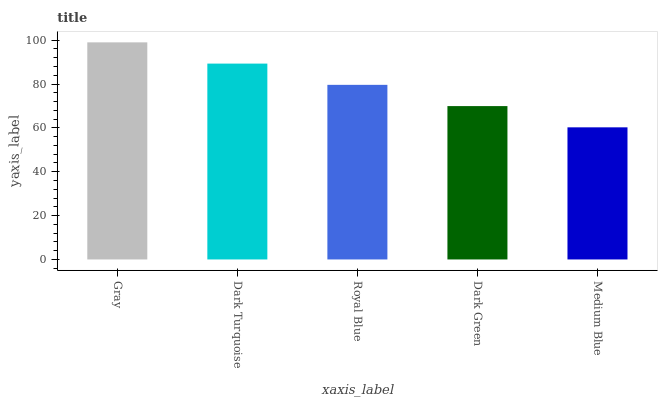Is Medium Blue the minimum?
Answer yes or no. Yes. Is Gray the maximum?
Answer yes or no. Yes. Is Dark Turquoise the minimum?
Answer yes or no. No. Is Dark Turquoise the maximum?
Answer yes or no. No. Is Gray greater than Dark Turquoise?
Answer yes or no. Yes. Is Dark Turquoise less than Gray?
Answer yes or no. Yes. Is Dark Turquoise greater than Gray?
Answer yes or no. No. Is Gray less than Dark Turquoise?
Answer yes or no. No. Is Royal Blue the high median?
Answer yes or no. Yes. Is Royal Blue the low median?
Answer yes or no. Yes. Is Gray the high median?
Answer yes or no. No. Is Dark Turquoise the low median?
Answer yes or no. No. 